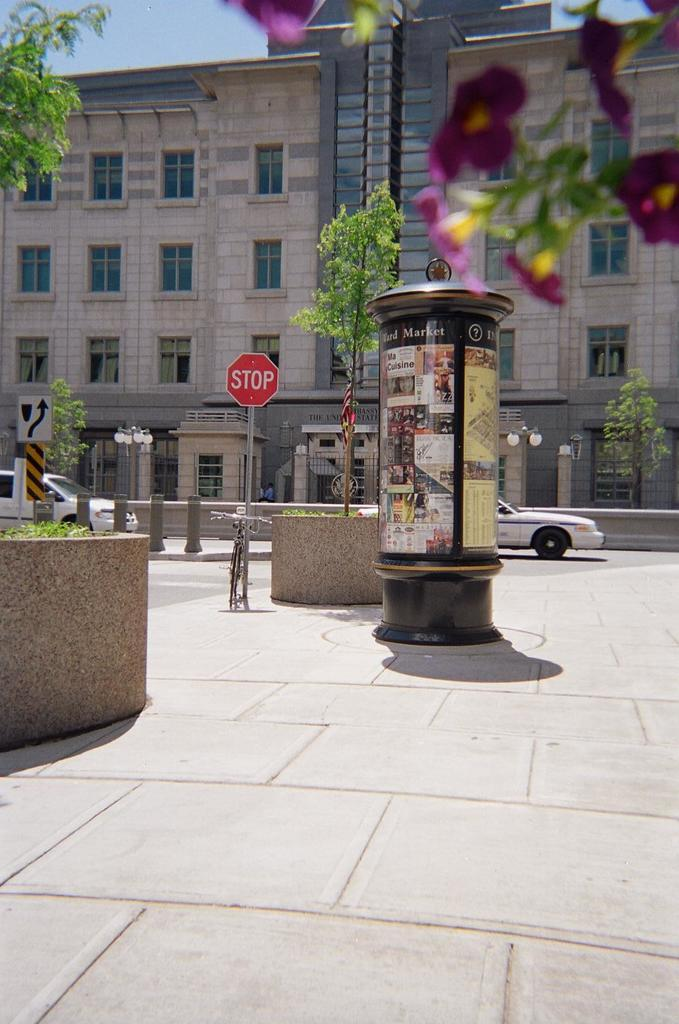What is located in the center of the image? There is a sign board and a tree in the center of the image. Are there any trees visible on the left side of the image? Yes, there is a tree on the left side of the image. What can be seen in the background of the image? There is a building, vehicles, lights, and a tree in the background of the image. What part of the natural environment is visible in the background of the image? The sky is visible in the background of the image. How does the self-adjusting pan work in the image? There is no self-adjusting pan present in the image. 